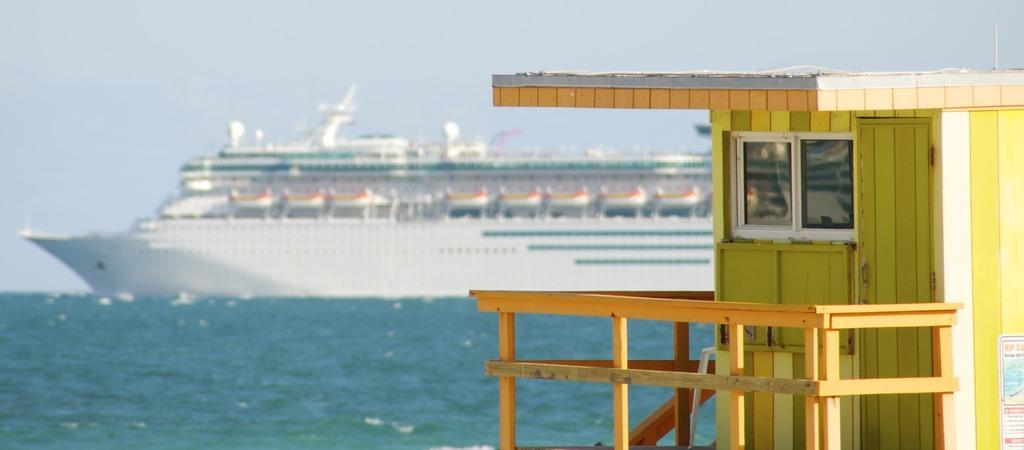What type of structure is located on the right side of the image? There is a wooden shelter on the right side of the image. What feature can be seen on the wooden shelter? The wooden shelter has windows. What can be seen in the background of the image? There is a ship in the background of the image. What is the ship situated on? The ship is on water. What type of powder can be seen falling from the sky in the image? There is no powder falling from the sky in the image. 